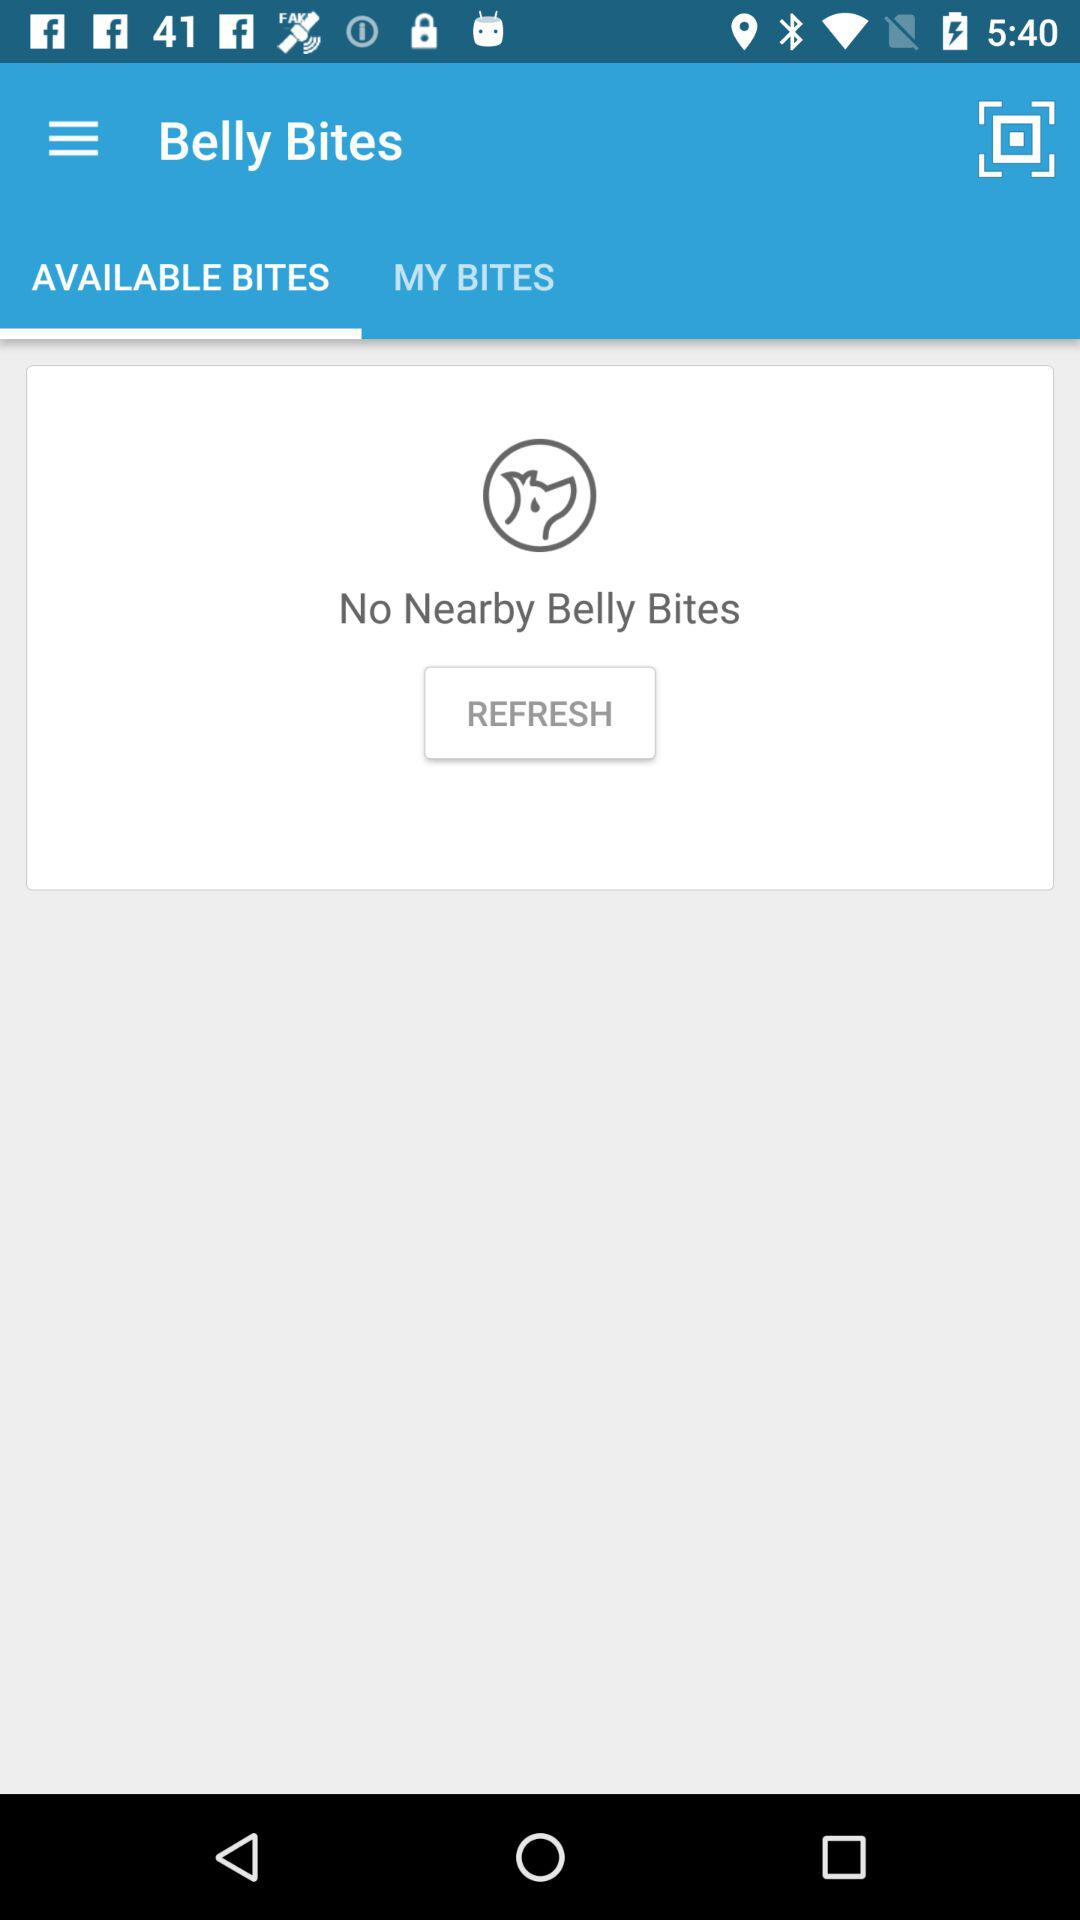What is the name of the application? The name of the application is "Belly Bites". 